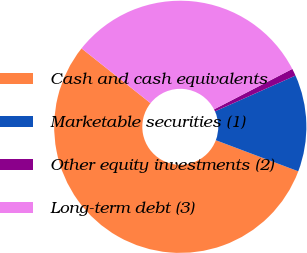Convert chart to OTSL. <chart><loc_0><loc_0><loc_500><loc_500><pie_chart><fcel>Cash and cash equivalents<fcel>Marketable securities (1)<fcel>Other equity investments (2)<fcel>Long-term debt (3)<nl><fcel>54.94%<fcel>12.4%<fcel>0.93%<fcel>31.72%<nl></chart> 